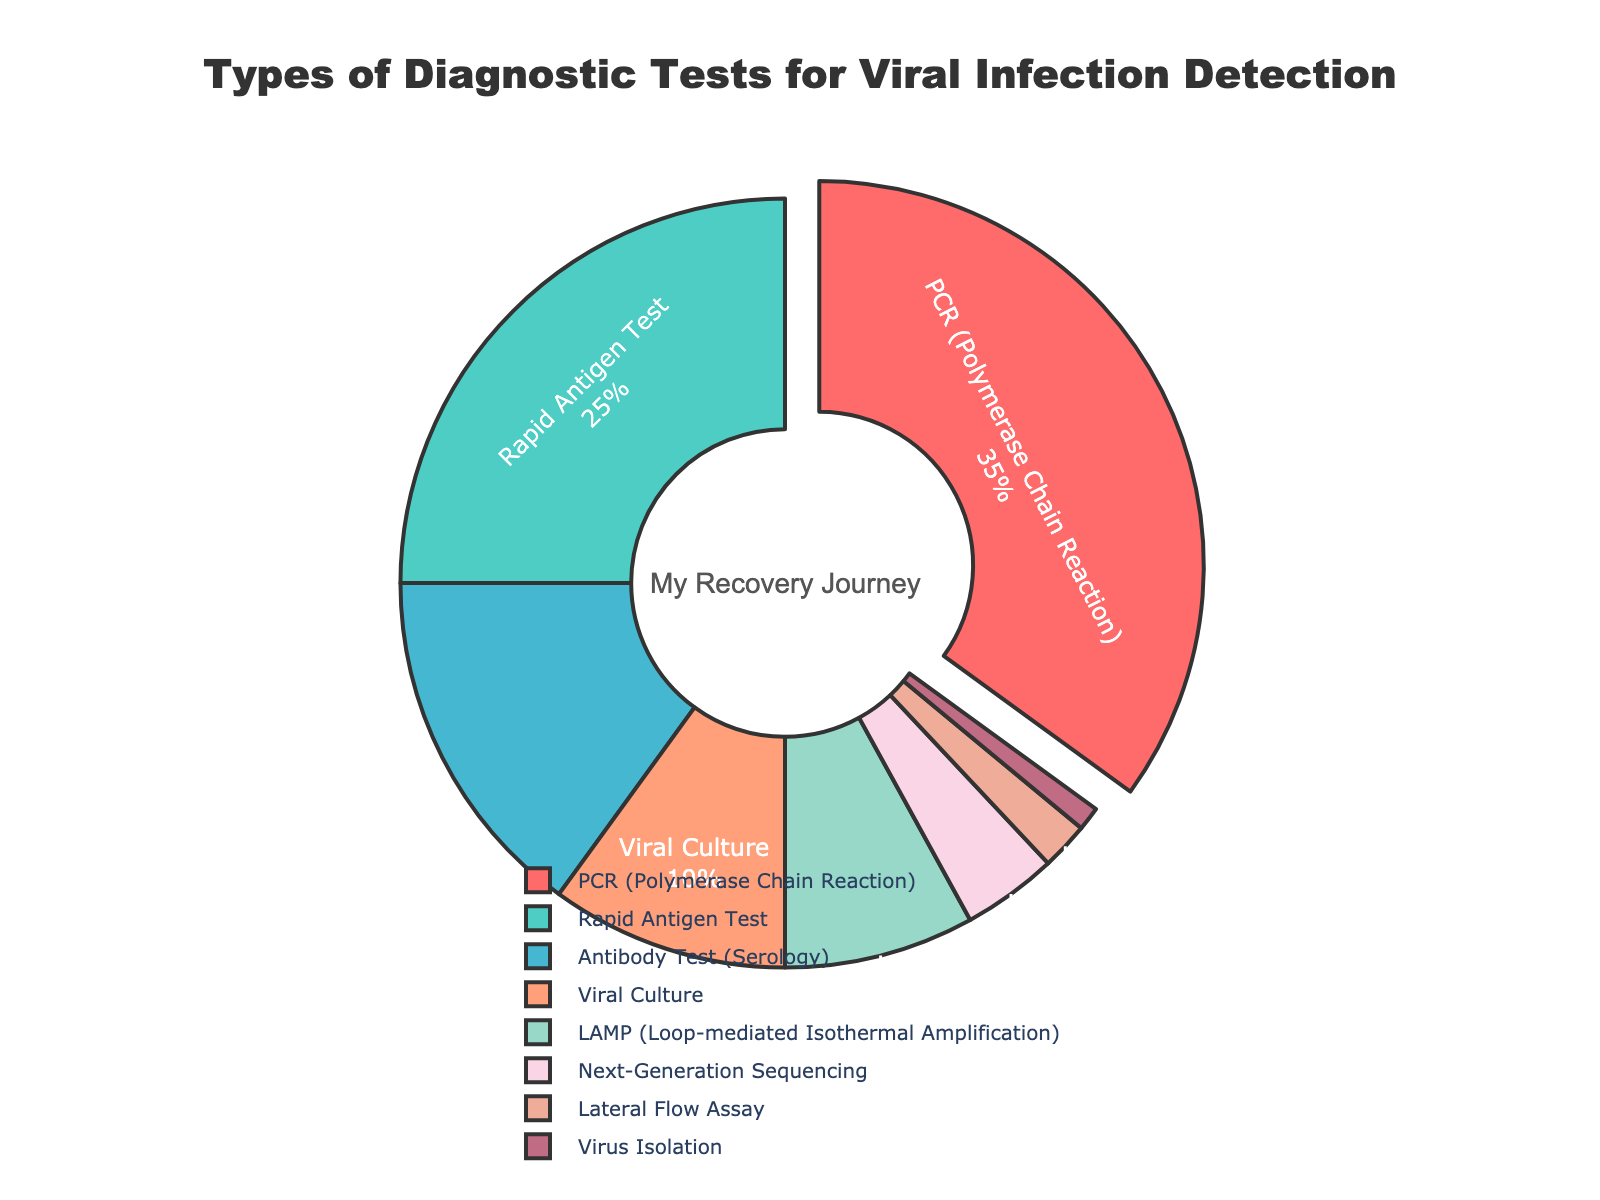What is the most common type of diagnostic test used for viral infection detection? By looking at the pie chart, the slice with the largest portion and highlighted by being pulled out is the PCR (Polymerase Chain Reaction) test. It occupies 35% of the pie chart, making it the most common type of diagnostic test.
Answer: PCR (Polymerase Chain Reaction) Which test type is used more frequently, Rapid Antigen Test or Antibody Test (Serology)? The Rapid Antigen Test occupies 25% of the pie chart, while the Antibody Test (Serology) occupies 15%. Since 25% is greater than 15%, the Rapid Antigen Test is used more frequently.
Answer: Rapid Antigen Test How much more common is the Rapid Antigen Test compared to Next-Generation Sequencing? The Rapid Antigen Test takes up 25% of the pie chart, and Next-Generation Sequencing takes up 4%. The difference is calculated as 25% - 4%, giving us 21%.
Answer: 21% What is the combined percentage of Viral Culture and LAMP (Loop-mediated Isothermal Amplification) tests? The Viral Culture test occupies 10% of the pie chart, and the LAMP test takes up 8%. Adding these percentages together, the total is 10% + 8%, resulting in 18%.
Answer: 18% What percentage of diagnostic tests is different from the total percentage of Virus Isolation and Lateral Flow Assay combined? Virus Isolation is 1%, and Lateral Flow Assay is 2%, combining to 1% + 2% = 3%. Subtract this combined percentage from 100%, we get 100% - 3%, which is 97%.
Answer: 97% Which diagnostic test type occupies the smallest portion of the pie chart? The smallest slice of the pie chart is for Virus Isolation, occupying only 1%.
Answer: Virus Isolation Are the proportions of LAMP and Next-Generation Sequencing tests combined greater than the proportion occupied by Rapid Antigen Tests? The LAMP test makes up 8%, and the Next-Generation Sequencing test makes up 4%. The combined percentage is 8% + 4% = 12%. The Rapid Antigen Test alone occupies 25%. Since 12% is not greater than 25%, they are not greater.
Answer: No What is the cumulative percentage for PCR, Rapid Antigen Test, and Antibody Test (Serology)? The PCR test is 35%, the Rapid Antigen Test is 25%, and the Antibody Test (Serology) is 15%. Summing these gives 35% + 25% + 15%, equalling 75%.
Answer: 75% What does the annotation in the center of the pie chart say? The annotation at the center reads, indicating a personal reflection related to the pie chart.
Answer: My Recovery Journey 